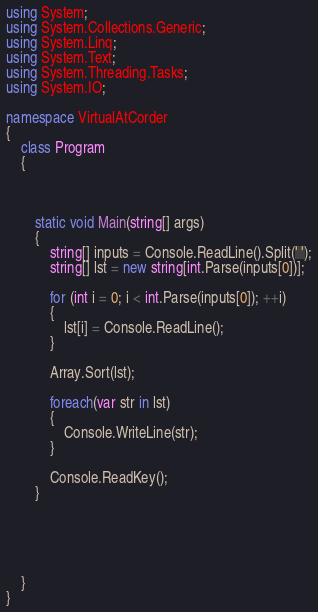Convert code to text. <code><loc_0><loc_0><loc_500><loc_500><_C#_>using System;
using System.Collections.Generic;
using System.Linq;
using System.Text;
using System.Threading.Tasks;
using System.IO;

namespace VirtualAtCorder
{
    class Program
    {



        static void Main(string[] args)
        {
            string[] inputs = Console.ReadLine().Split(' ');
            string[] lst = new string[int.Parse(inputs[0])];

            for (int i = 0; i < int.Parse(inputs[0]); ++i)
            {
                lst[i] = Console.ReadLine();
            }

            Array.Sort(lst);

            foreach(var str in lst)
            {
                Console.WriteLine(str);
            }

            Console.ReadKey();
        }
        
        



    }
}
</code> 